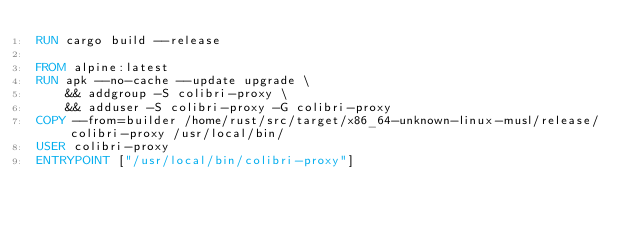Convert code to text. <code><loc_0><loc_0><loc_500><loc_500><_Dockerfile_>RUN cargo build --release

FROM alpine:latest
RUN apk --no-cache --update upgrade \
    && addgroup -S colibri-proxy \
    && adduser -S colibri-proxy -G colibri-proxy
COPY --from=builder /home/rust/src/target/x86_64-unknown-linux-musl/release/colibri-proxy /usr/local/bin/
USER colibri-proxy
ENTRYPOINT ["/usr/local/bin/colibri-proxy"]
</code> 